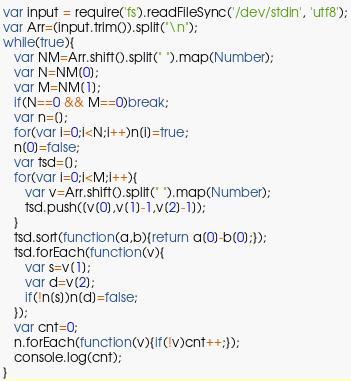<code> <loc_0><loc_0><loc_500><loc_500><_JavaScript_>var input = require('fs').readFileSync('/dev/stdin', 'utf8');
var Arr=(input.trim()).split("\n");
while(true){
   var NM=Arr.shift().split(" ").map(Number);
   var N=NM[0];
   var M=NM[1];
   if(N==0 && M==0)break;
   var n=[];
   for(var i=0;i<N;i++)n[i]=true;
   n[0]=false;
   var tsd=[];
   for(var i=0;i<M;i++){
      var v=Arr.shift().split(" ").map(Number);
      tsd.push([v[0],v[1]-1,v[2]-1]);
   }
   tsd.sort(function(a,b){return a[0]-b[0];});
   tsd.forEach(function(v){
      var s=v[1];
      var d=v[2];
      if(!n[s])n[d]=false;
   });
   var cnt=0;
   n.forEach(function(v){if(!v)cnt++;});
   console.log(cnt);
}</code> 